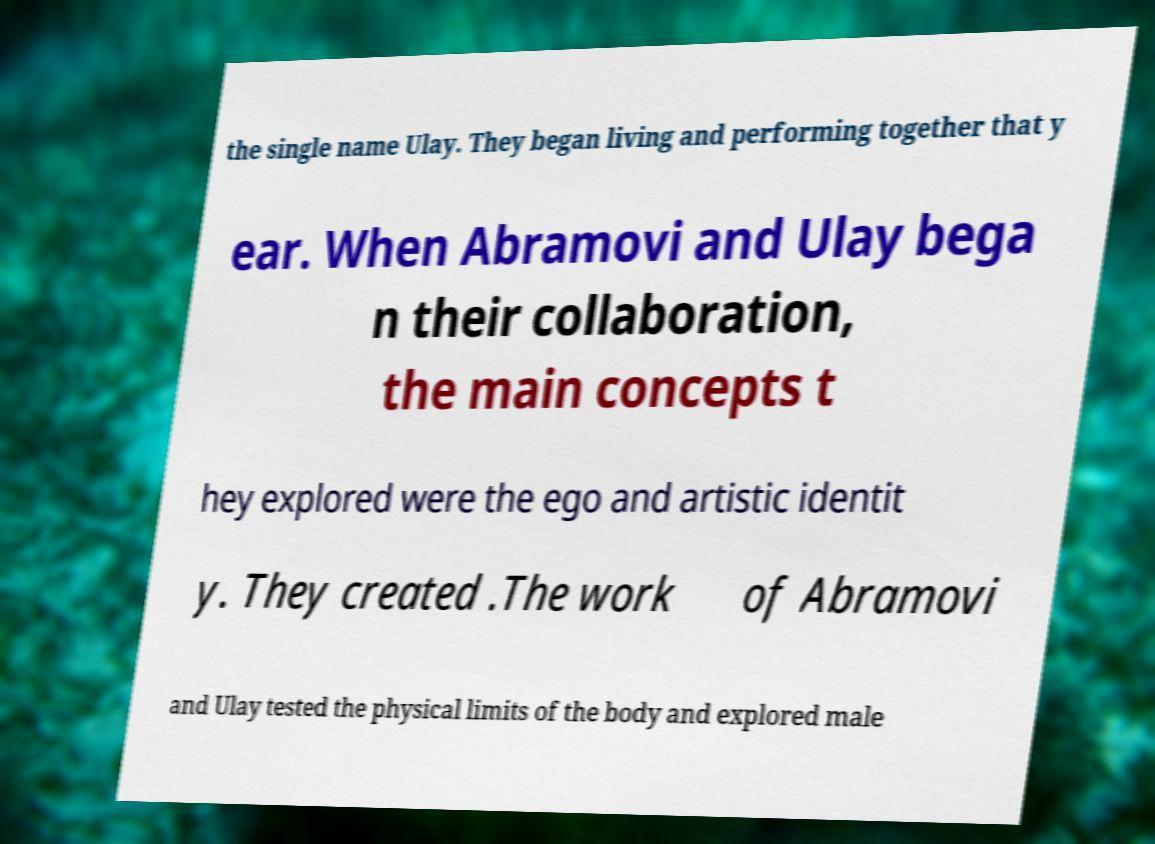Could you extract and type out the text from this image? the single name Ulay. They began living and performing together that y ear. When Abramovi and Ulay bega n their collaboration, the main concepts t hey explored were the ego and artistic identit y. They created .The work of Abramovi and Ulay tested the physical limits of the body and explored male 